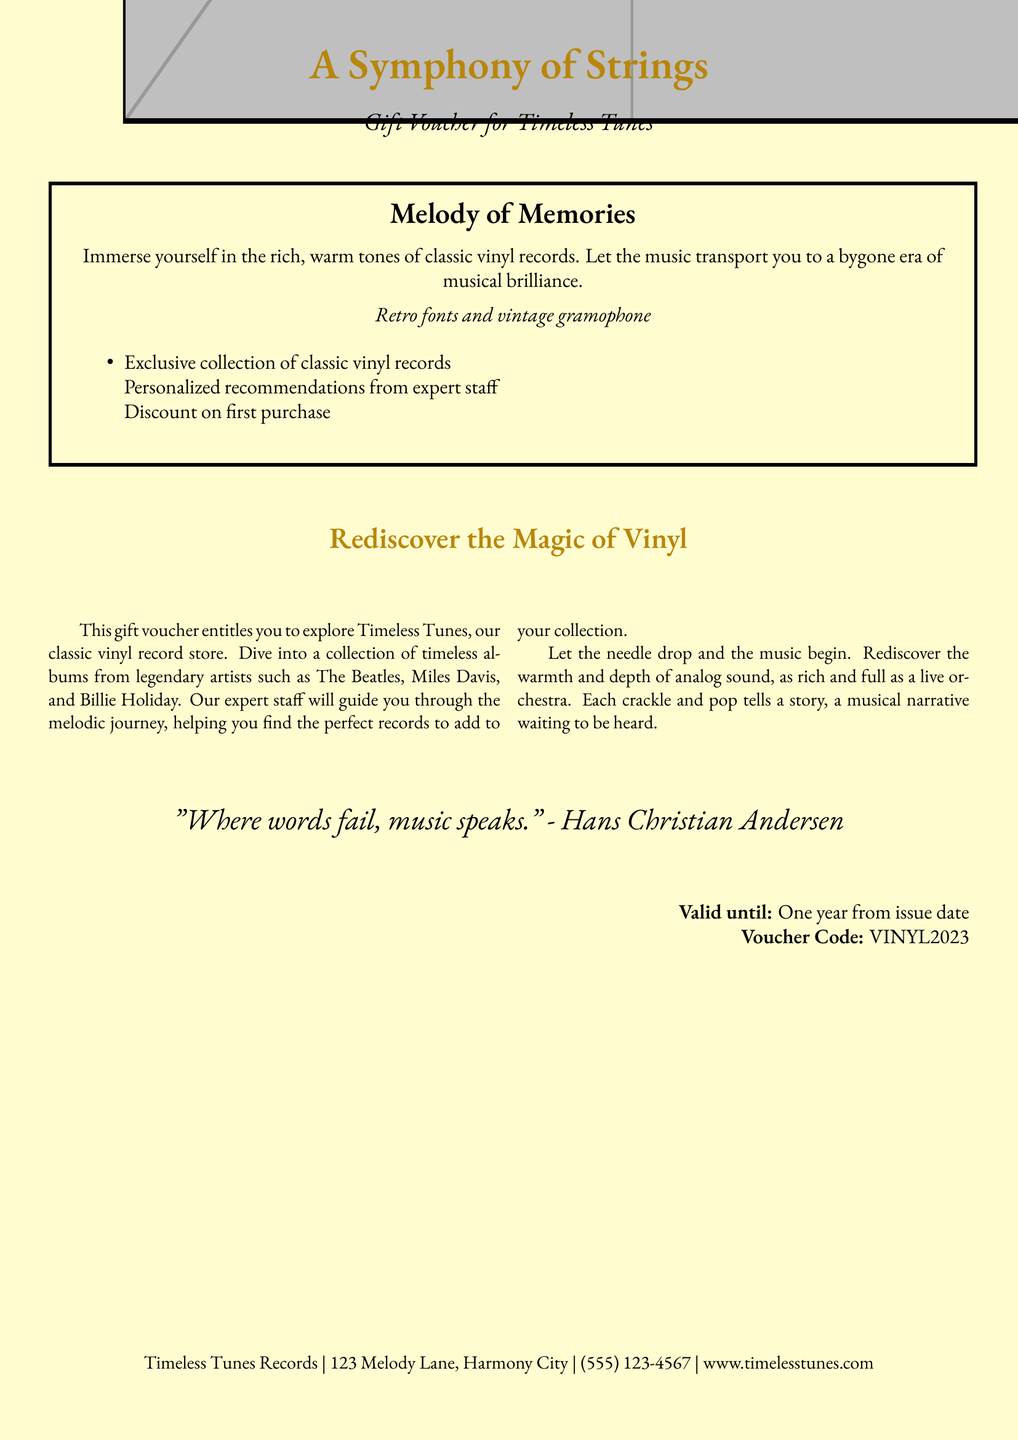What is the name of the gift voucher? The gift voucher is titled "A Symphony of Strings."
Answer: A Symphony of Strings Who is the quote attributed to at the bottom of the document? The quote is attributed to Hans Christian Andersen.
Answer: Hans Christian Andersen What is offered in the exclusive collection? The collection includes classic vinyl records.
Answer: Classic vinyl records Where is the record store located? The store is located at 123 Melody Lane, Harmony City.
Answer: 123 Melody Lane, Harmony City What is the voucher code? The voucher code is VINYL2023.
Answer: VINYL2023 Until when is the voucher valid? The voucher is valid until one year from the issue date.
Answer: One year from issue date What type of recommendations can you expect from the staff? You can expect personalized recommendations from expert staff.
Answer: Personalized recommendations Which musical artists are mentioned in the document? The artists mentioned include The Beatles, Miles Davis, and Billie Holiday.
Answer: The Beatles, Miles Davis, and Billie Holiday 